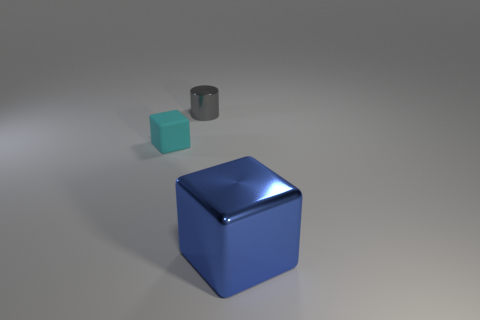Add 3 big red shiny cylinders. How many objects exist? 6 Subtract 1 blocks. How many blocks are left? 1 Subtract all cubes. How many objects are left? 1 Subtract all small red metal things. Subtract all gray metal cylinders. How many objects are left? 2 Add 1 big blocks. How many big blocks are left? 2 Add 2 small gray metal cylinders. How many small gray metal cylinders exist? 3 Subtract 0 purple spheres. How many objects are left? 3 